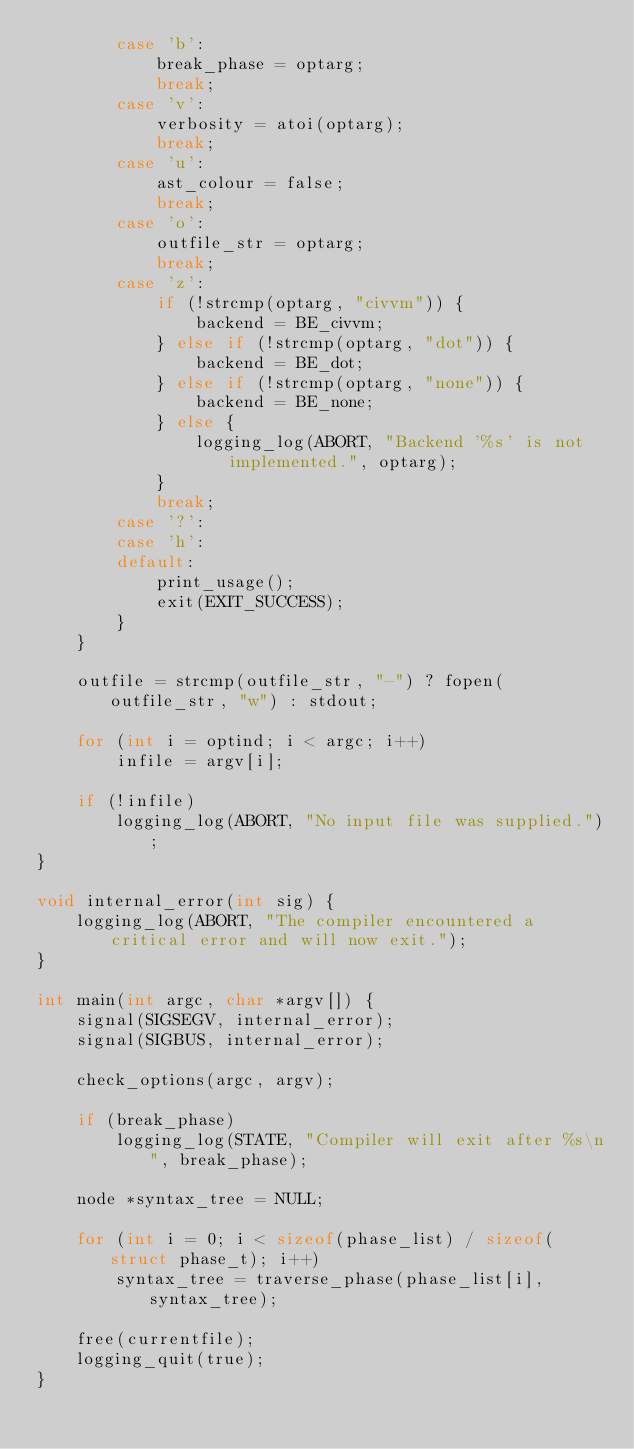Convert code to text. <code><loc_0><loc_0><loc_500><loc_500><_C_>        case 'b':
            break_phase = optarg;
            break;
        case 'v':
            verbosity = atoi(optarg);
            break;
        case 'u':
            ast_colour = false;
            break;
        case 'o':
            outfile_str = optarg;
            break;
        case 'z':
            if (!strcmp(optarg, "civvm")) {
                backend = BE_civvm;
            } else if (!strcmp(optarg, "dot")) {
                backend = BE_dot;
            } else if (!strcmp(optarg, "none")) {
                backend = BE_none;
            } else {
                logging_log(ABORT, "Backend '%s' is not implemented.", optarg);
            }
            break;
        case '?':
        case 'h':
        default:
            print_usage();
            exit(EXIT_SUCCESS);
        }
    }

    outfile = strcmp(outfile_str, "-") ? fopen(outfile_str, "w") : stdout;

    for (int i = optind; i < argc; i++)
        infile = argv[i];

    if (!infile)
        logging_log(ABORT, "No input file was supplied.");
}

void internal_error(int sig) {
    logging_log(ABORT, "The compiler encountered a critical error and will now exit.");
}

int main(int argc, char *argv[]) {
    signal(SIGSEGV, internal_error);
    signal(SIGBUS, internal_error);

    check_options(argc, argv);

    if (break_phase)
        logging_log(STATE, "Compiler will exit after %s\n", break_phase);

    node *syntax_tree = NULL;

    for (int i = 0; i < sizeof(phase_list) / sizeof(struct phase_t); i++)
        syntax_tree = traverse_phase(phase_list[i], syntax_tree);

    free(currentfile);
    logging_quit(true);
}
</code> 